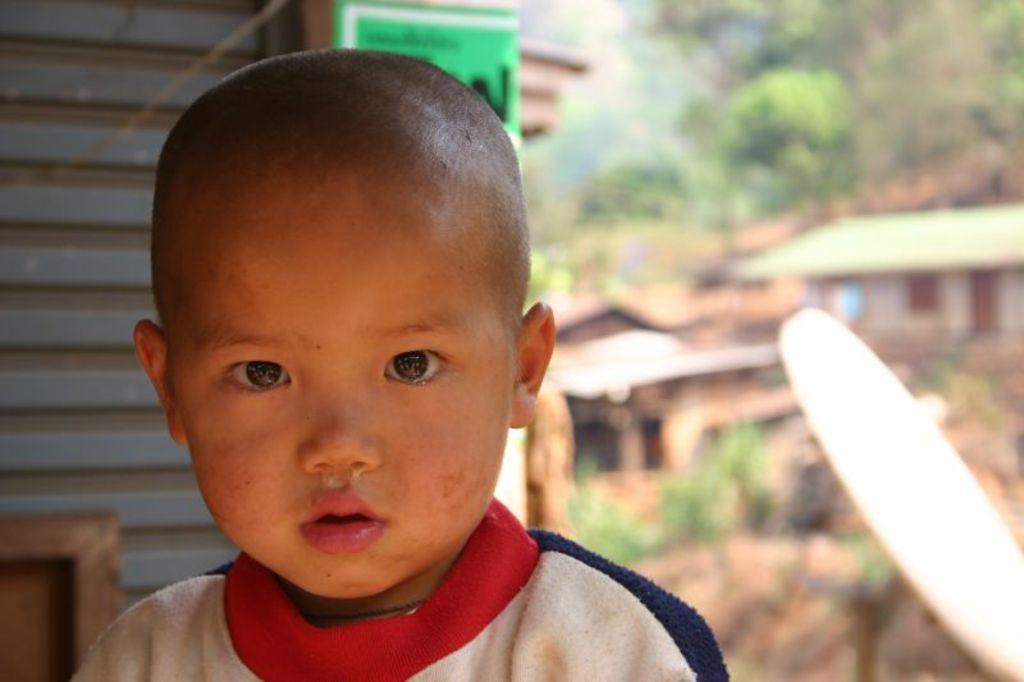Please provide a concise description of this image. In this image there is a boy in the front. In the background there are trees, buildings and plants. 